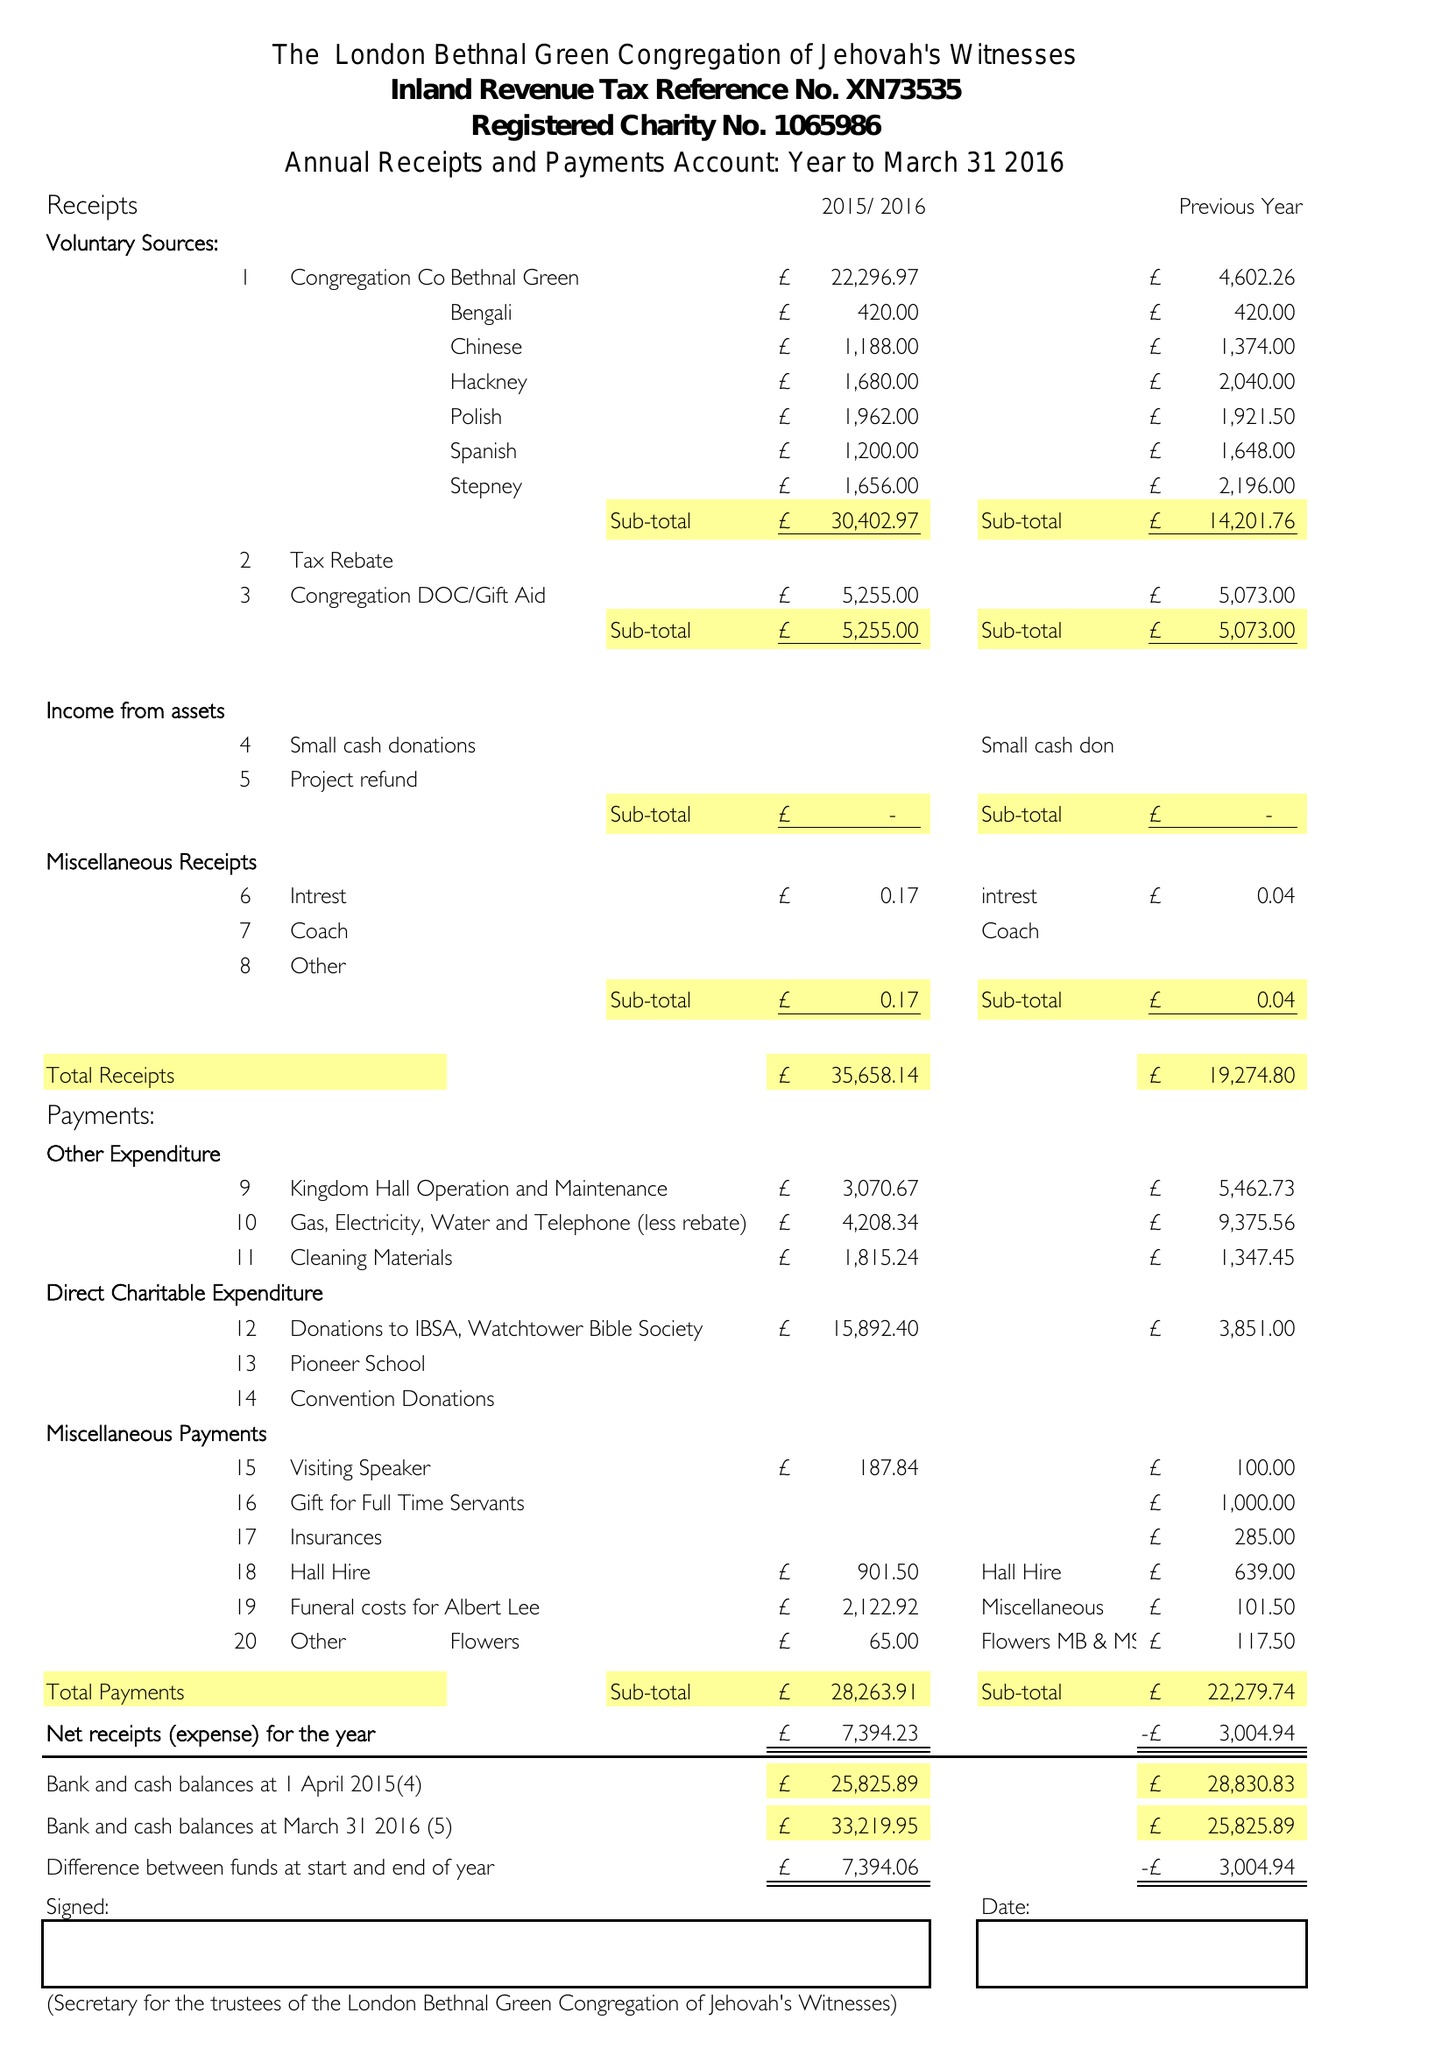What is the value for the address__postcode?
Answer the question using a single word or phrase. E3 5TG 